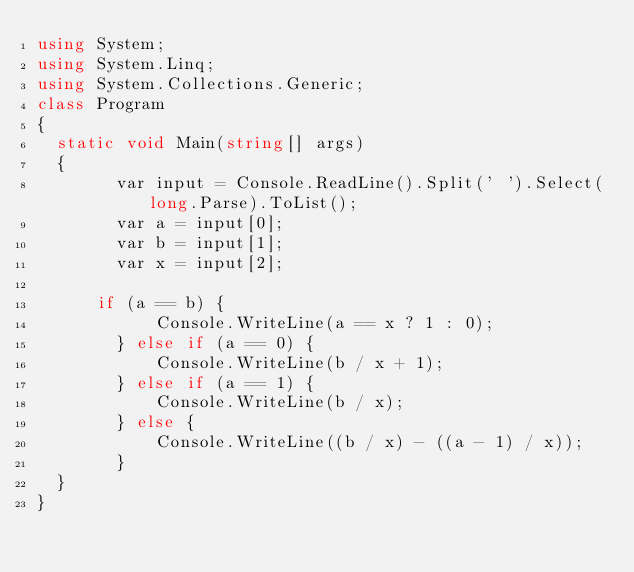Convert code to text. <code><loc_0><loc_0><loc_500><loc_500><_C#_>using System;
using System.Linq;
using System.Collections.Generic;
class Program
{
	static void Main(string[] args)
	{
        var input = Console.ReadLine().Split(' ').Select(long.Parse).ToList();
        var a = input[0];
        var b = input[1];
        var x = input[2];
        
	    if (a == b) {
            Console.WriteLine(a == x ? 1 : 0);
        } else if (a == 0) {
            Console.WriteLine(b / x + 1);
        } else if (a == 1) {
            Console.WriteLine(b / x);
        } else {
            Console.WriteLine((b / x) - ((a - 1) / x));
        }
	}
}</code> 